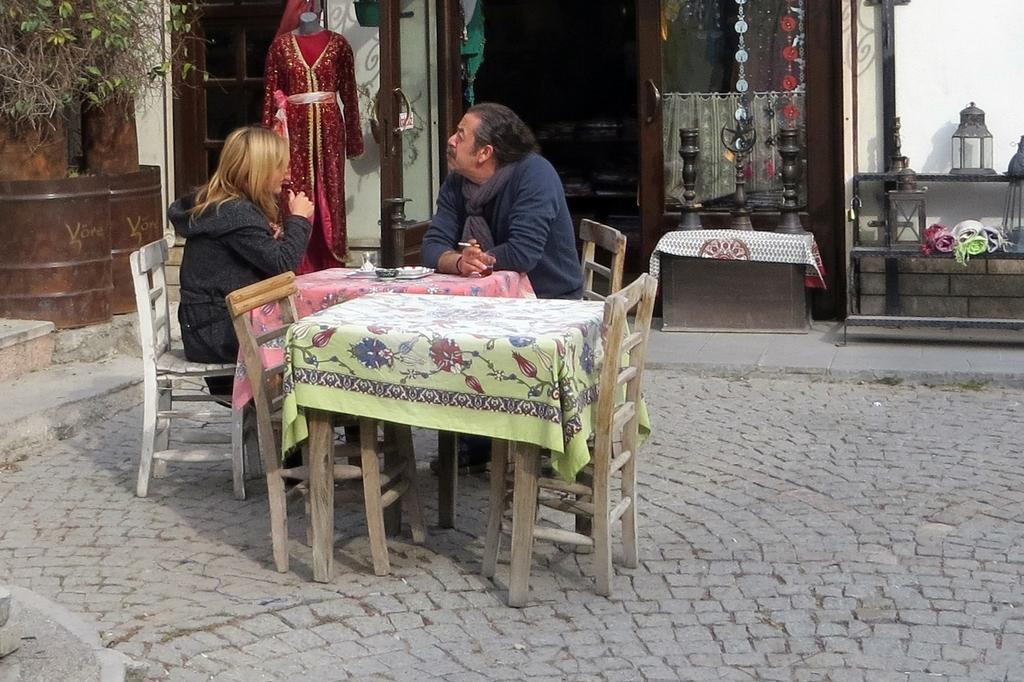How many people are present in the image? There are two people, a man and a woman, present in the image. What are the man and woman doing in the image? Both the man and woman are sitting on chairs in the image. Where are the chairs located in relation to other objects? The chairs are near a table in the image. What can be seen in the background of the image? In the background, there are dresses, plants, a shop, and a pole visible. What type of metal is used to construct the lumber in the image? There is no metal or lumber present in the image; it features a man and a woman sitting near a table with chairs. How many visitors are visible in the image? There are no visitors visible in the image; it only features a man and a woman sitting near a table with chairs. 